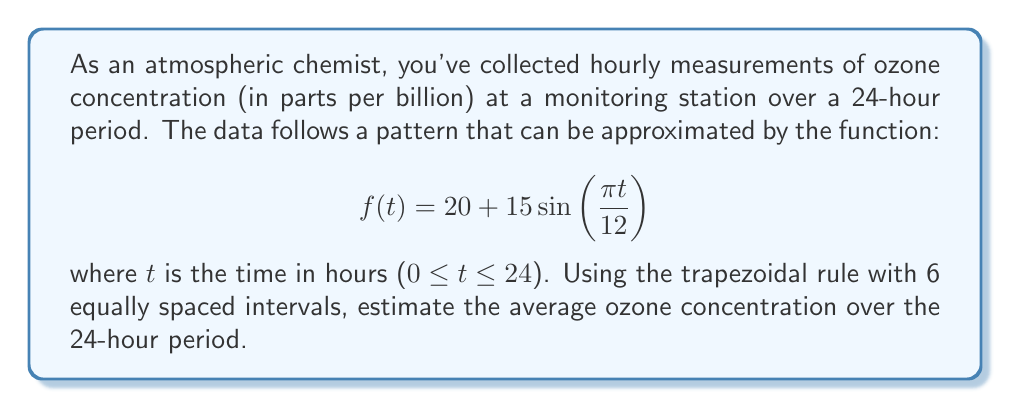Can you solve this math problem? To solve this problem, we'll follow these steps:

1) The trapezoidal rule for numerical integration is given by:

   $$\int_a^b f(x)dx \approx \frac{h}{2}\left[f(x_0) + 2f(x_1) + 2f(x_2) + ... + 2f(x_{n-1}) + f(x_n)\right]$$

   where $h = \frac{b-a}{n}$, and $n$ is the number of intervals.

2) In our case, $a=0$, $b=24$, and $n=6$. So, $h = \frac{24-0}{6} = 4$.

3) We need to evaluate $f(t)$ at $t = 0, 4, 8, 12, 16, 20, 24$:

   $f(0) = 20 + 15\sin(0) = 20$
   $f(4) = 20 + 15\sin(\pi/3) \approx 32.99$
   $f(8) = 20 + 15\sin(2\pi/3) \approx 32.99$
   $f(12) = 20 + 15\sin(\pi) = 20$
   $f(16) = 20 + 15\sin(4\pi/3) \approx 7.01$
   $f(20) = 20 + 15\sin(5\pi/3) \approx 7.01$
   $f(24) = 20 + 15\sin(2\pi) = 20$

4) Applying the trapezoidal rule:

   $$\int_0^{24} f(t)dt \approx \frac{4}{2}[20 + 2(32.99 + 32.99 + 20 + 7.01 + 7.01) + 20]$$
   $$= 2[20 + 2(100) + 20] = 2[20 + 200 + 20] = 2(240) = 480$$

5) This gives us the total concentration over 24 hours. To get the average, we divide by 24:

   Average concentration = $\frac{480}{24} = 20$ ppb
Answer: The estimated average ozone concentration over the 24-hour period is 20 parts per billion (ppb). 